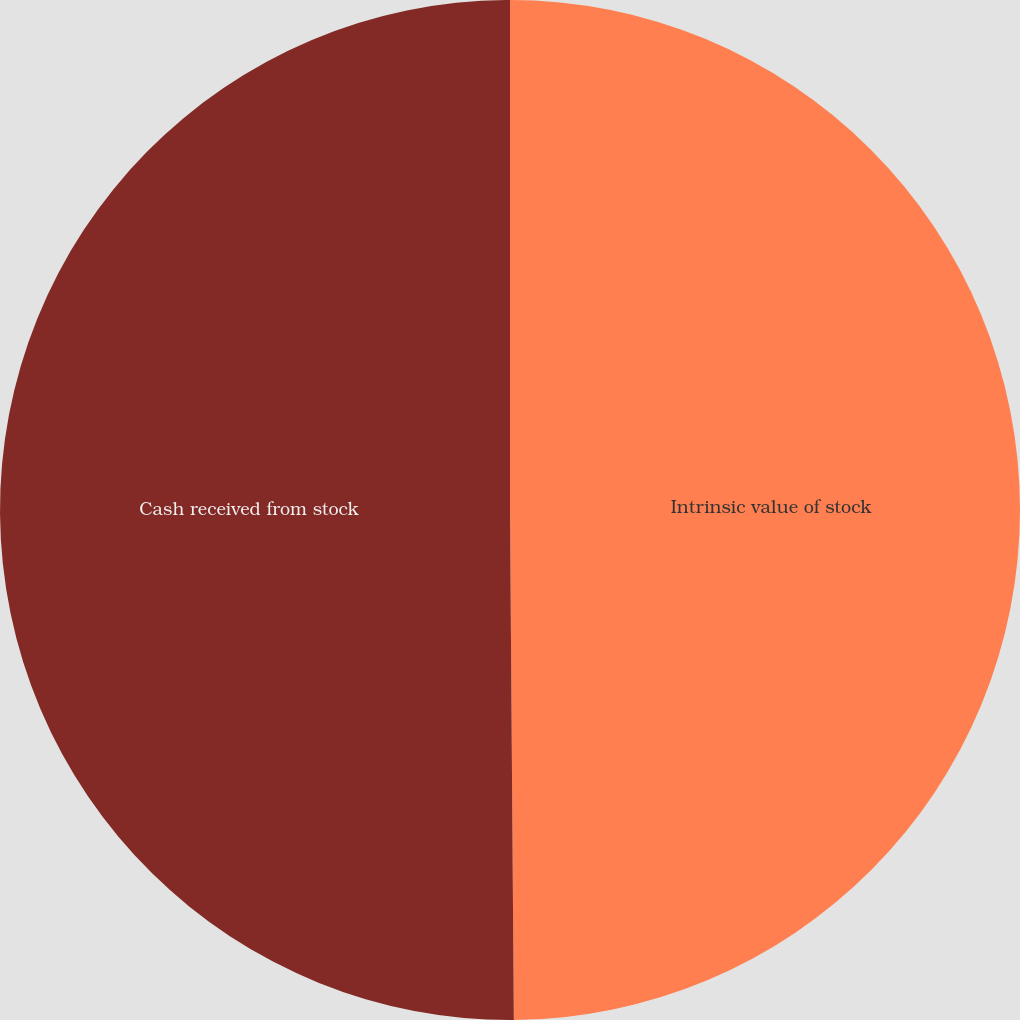Convert chart to OTSL. <chart><loc_0><loc_0><loc_500><loc_500><pie_chart><fcel>Intrinsic value of stock<fcel>Cash received from stock<nl><fcel>49.88%<fcel>50.12%<nl></chart> 